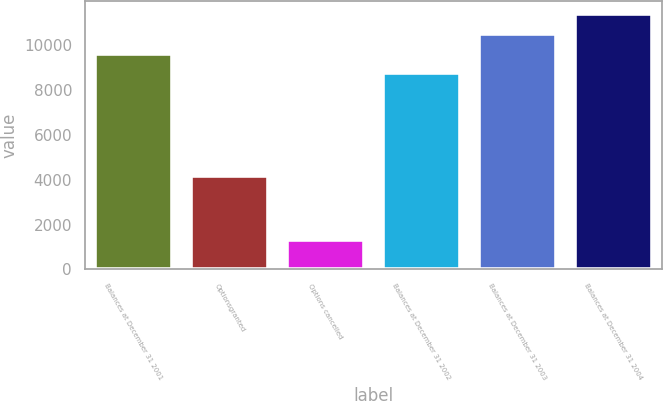Convert chart to OTSL. <chart><loc_0><loc_0><loc_500><loc_500><bar_chart><fcel>Balances at December 31 2001<fcel>Optionsgranted<fcel>Options cancelled<fcel>Balances at December 31 2002<fcel>Balances at December 31 2003<fcel>Balances at December 31 2004<nl><fcel>9604.3<fcel>4150<fcel>1299<fcel>8723<fcel>10485.6<fcel>11366.9<nl></chart> 